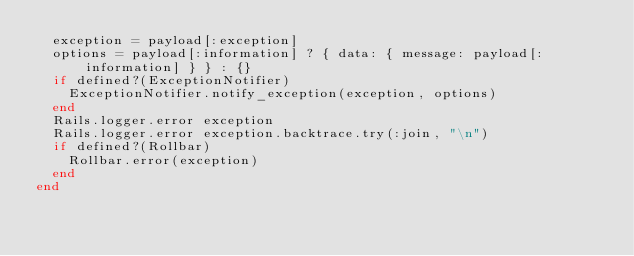<code> <loc_0><loc_0><loc_500><loc_500><_Ruby_>  exception = payload[:exception]
  options = payload[:information] ? { data: { message: payload[:information] } } : {}
  if defined?(ExceptionNotifier)
    ExceptionNotifier.notify_exception(exception, options)
  end
  Rails.logger.error exception
  Rails.logger.error exception.backtrace.try(:join, "\n")
  if defined?(Rollbar)
    Rollbar.error(exception)
  end
end
</code> 